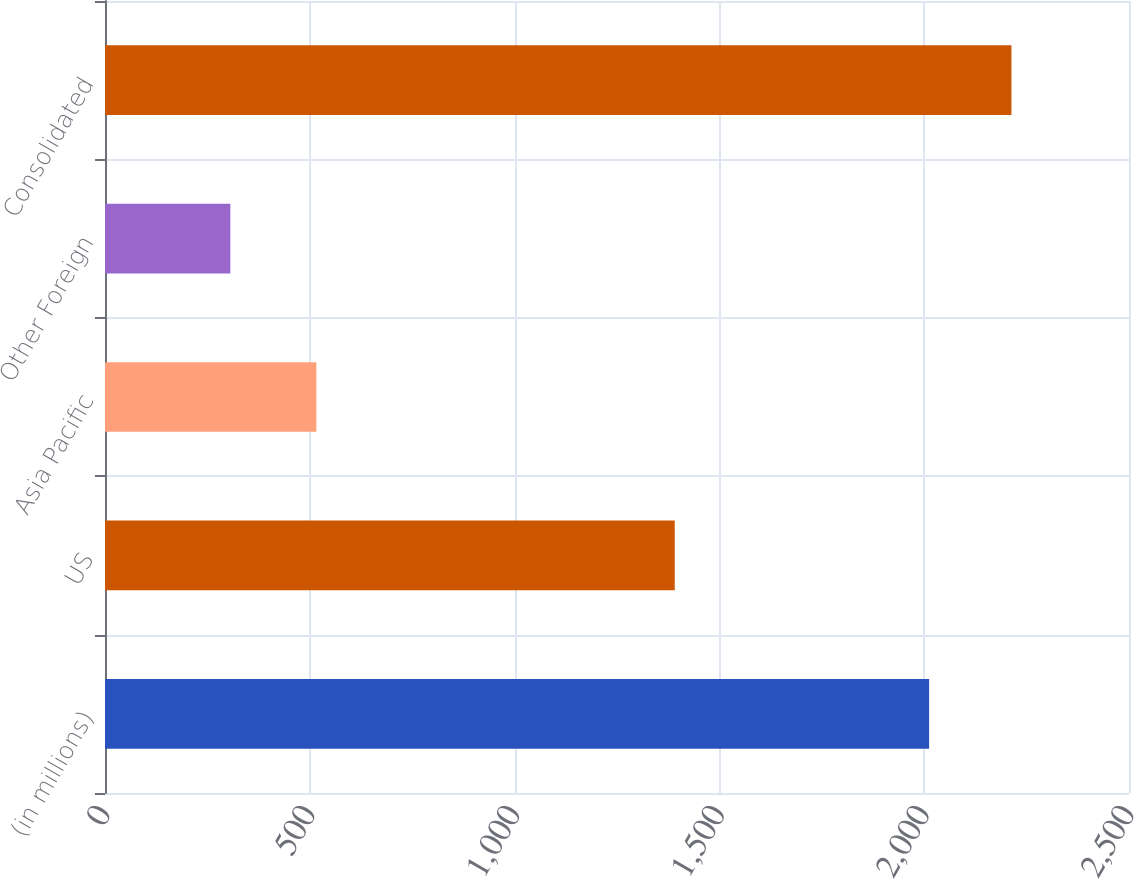Convert chart. <chart><loc_0><loc_0><loc_500><loc_500><bar_chart><fcel>(in millions)<fcel>US<fcel>Asia Pacific<fcel>Other Foreign<fcel>Consolidated<nl><fcel>2012<fcel>1391<fcel>516<fcel>306<fcel>2213<nl></chart> 